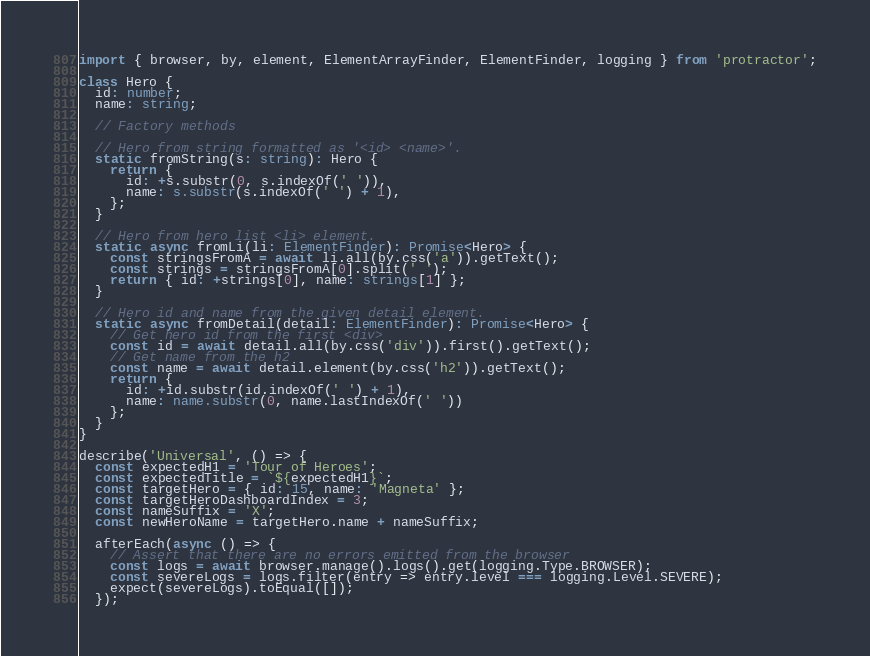Convert code to text. <code><loc_0><loc_0><loc_500><loc_500><_TypeScript_>import { browser, by, element, ElementArrayFinder, ElementFinder, logging } from 'protractor';

class Hero {
  id: number;
  name: string;

  // Factory methods

  // Hero from string formatted as '<id> <name>'.
  static fromString(s: string): Hero {
    return {
      id: +s.substr(0, s.indexOf(' ')),
      name: s.substr(s.indexOf(' ') + 1),
    };
  }

  // Hero from hero list <li> element.
  static async fromLi(li: ElementFinder): Promise<Hero> {
    const stringsFromA = await li.all(by.css('a')).getText();
    const strings = stringsFromA[0].split(' ');
    return { id: +strings[0], name: strings[1] };
  }

  // Hero id and name from the given detail element.
  static async fromDetail(detail: ElementFinder): Promise<Hero> {
    // Get hero id from the first <div>
    const id = await detail.all(by.css('div')).first().getText();
    // Get name from the h2
    const name = await detail.element(by.css('h2')).getText();
    return {
      id: +id.substr(id.indexOf(' ') + 1),
      name: name.substr(0, name.lastIndexOf(' '))
    };
  }
}

describe('Universal', () => {
  const expectedH1 = 'Tour of Heroes';
  const expectedTitle = `${expectedH1}`;
  const targetHero = { id: 15, name: 'Magneta' };
  const targetHeroDashboardIndex = 3;
  const nameSuffix = 'X';
  const newHeroName = targetHero.name + nameSuffix;

  afterEach(async () => {
    // Assert that there are no errors emitted from the browser
    const logs = await browser.manage().logs().get(logging.Type.BROWSER);
    const severeLogs = logs.filter(entry => entry.level === logging.Level.SEVERE);
    expect(severeLogs).toEqual([]);
  });
</code> 